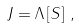Convert formula to latex. <formula><loc_0><loc_0><loc_500><loc_500>J = \Lambda \left [ S \right ] \, ,</formula> 